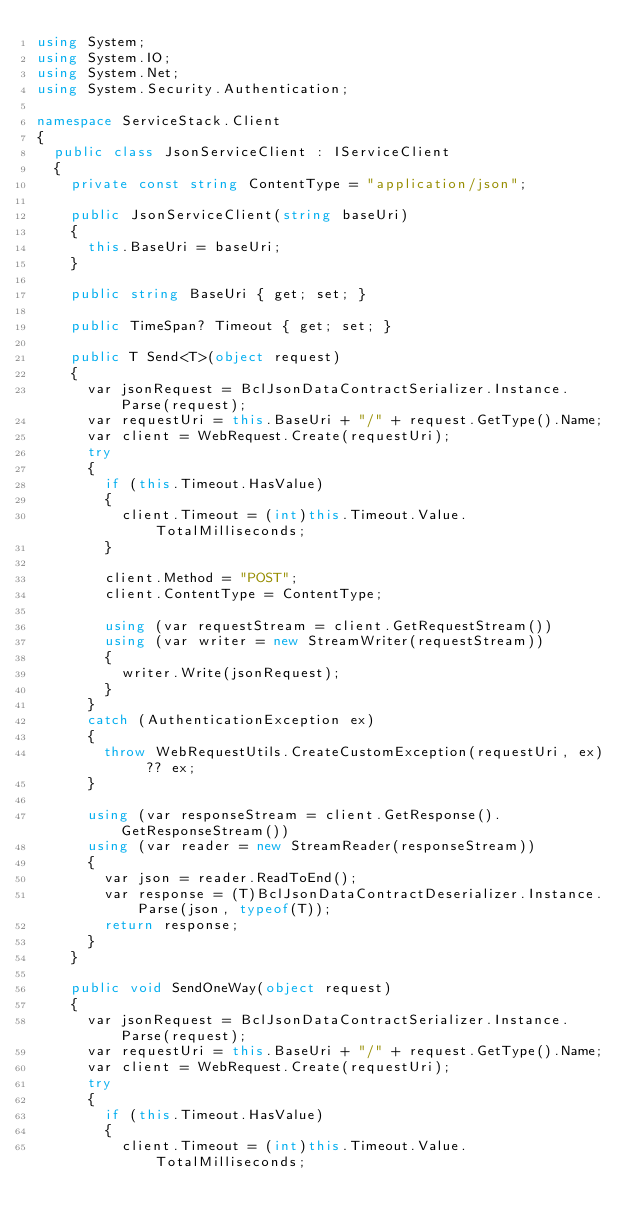Convert code to text. <code><loc_0><loc_0><loc_500><loc_500><_C#_>using System;
using System.IO;
using System.Net;
using System.Security.Authentication;

namespace ServiceStack.Client
{
	public class JsonServiceClient : IServiceClient
	{
		private const string ContentType = "application/json";

		public JsonServiceClient(string baseUri)
		{
			this.BaseUri = baseUri;
		}

		public string BaseUri { get; set; }

		public TimeSpan? Timeout { get; set; }

		public T Send<T>(object request)
		{
			var jsonRequest = BclJsonDataContractSerializer.Instance.Parse(request);
			var requestUri = this.BaseUri + "/" + request.GetType().Name;
			var client = WebRequest.Create(requestUri);
			try
			{
				if (this.Timeout.HasValue)
				{
					client.Timeout = (int)this.Timeout.Value.TotalMilliseconds;
				}

				client.Method = "POST";
				client.ContentType = ContentType;

				using (var requestStream = client.GetRequestStream())
				using (var writer = new StreamWriter(requestStream))
				{
					writer.Write(jsonRequest);
				}
			}
			catch (AuthenticationException ex)
			{
				throw WebRequestUtils.CreateCustomException(requestUri, ex) ?? ex;
			}

			using (var responseStream = client.GetResponse().GetResponseStream())
			using (var reader = new StreamReader(responseStream))
			{
				var json = reader.ReadToEnd();
				var response = (T)BclJsonDataContractDeserializer.Instance.Parse(json, typeof(T));
				return response;
			}
		}

		public void SendOneWay(object request)
		{
			var jsonRequest = BclJsonDataContractSerializer.Instance.Parse(request);
			var requestUri = this.BaseUri + "/" + request.GetType().Name;
			var client = WebRequest.Create(requestUri);
			try
			{
				if (this.Timeout.HasValue)
				{
					client.Timeout = (int)this.Timeout.Value.TotalMilliseconds;</code> 